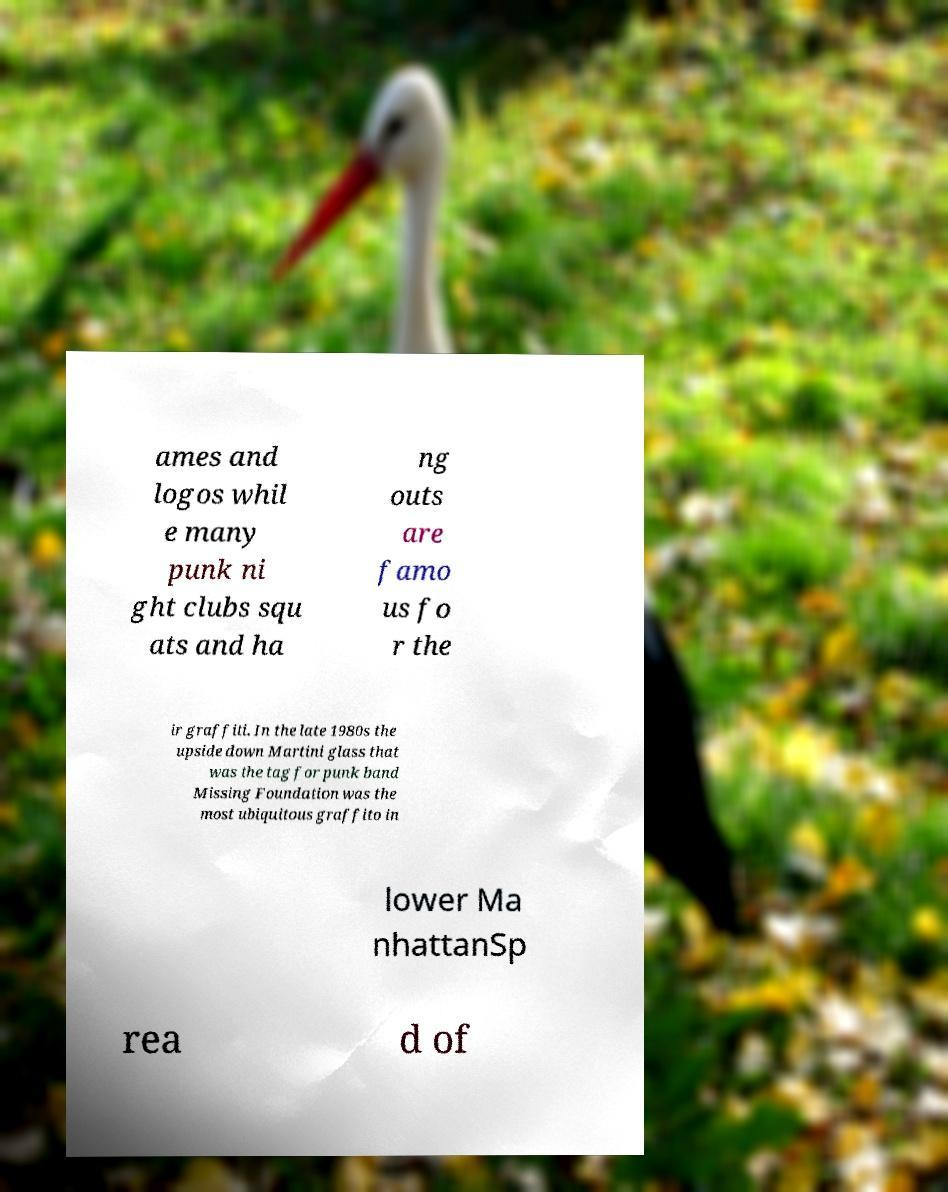Can you accurately transcribe the text from the provided image for me? ames and logos whil e many punk ni ght clubs squ ats and ha ng outs are famo us fo r the ir graffiti. In the late 1980s the upside down Martini glass that was the tag for punk band Missing Foundation was the most ubiquitous graffito in lower Ma nhattanSp rea d of 